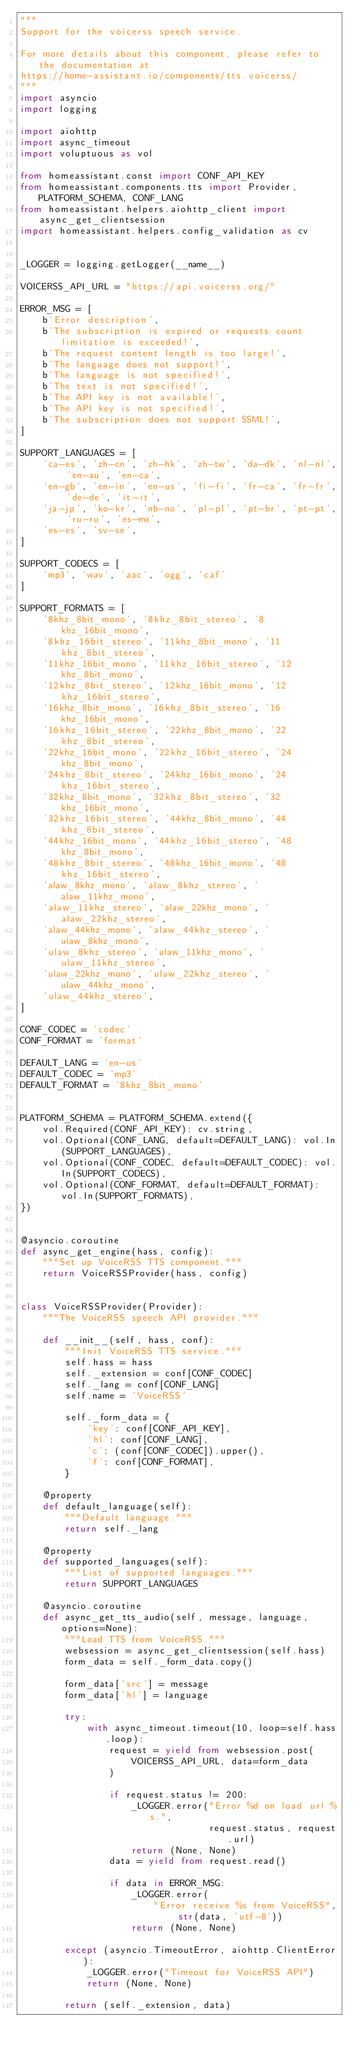<code> <loc_0><loc_0><loc_500><loc_500><_Python_>"""
Support for the voicerss speech service.

For more details about this component, please refer to the documentation at
https://home-assistant.io/components/tts.voicerss/
"""
import asyncio
import logging

import aiohttp
import async_timeout
import voluptuous as vol

from homeassistant.const import CONF_API_KEY
from homeassistant.components.tts import Provider, PLATFORM_SCHEMA, CONF_LANG
from homeassistant.helpers.aiohttp_client import async_get_clientsession
import homeassistant.helpers.config_validation as cv


_LOGGER = logging.getLogger(__name__)

VOICERSS_API_URL = "https://api.voicerss.org/"

ERROR_MSG = [
    b'Error description',
    b'The subscription is expired or requests count limitation is exceeded!',
    b'The request content length is too large!',
    b'The language does not support!',
    b'The language is not specified!',
    b'The text is not specified!',
    b'The API key is not available!',
    b'The API key is not specified!',
    b'The subscription does not support SSML!',
]

SUPPORT_LANGUAGES = [
    'ca-es', 'zh-cn', 'zh-hk', 'zh-tw', 'da-dk', 'nl-nl', 'en-au', 'en-ca',
    'en-gb', 'en-in', 'en-us', 'fi-fi', 'fr-ca', 'fr-fr', 'de-de', 'it-it',
    'ja-jp', 'ko-kr', 'nb-no', 'pl-pl', 'pt-br', 'pt-pt', 'ru-ru', 'es-mx',
    'es-es', 'sv-se',
]

SUPPORT_CODECS = [
    'mp3', 'wav', 'aac', 'ogg', 'caf'
]

SUPPORT_FORMATS = [
    '8khz_8bit_mono', '8khz_8bit_stereo', '8khz_16bit_mono',
    '8khz_16bit_stereo', '11khz_8bit_mono', '11khz_8bit_stereo',
    '11khz_16bit_mono', '11khz_16bit_stereo', '12khz_8bit_mono',
    '12khz_8bit_stereo', '12khz_16bit_mono', '12khz_16bit_stereo',
    '16khz_8bit_mono', '16khz_8bit_stereo', '16khz_16bit_mono',
    '16khz_16bit_stereo', '22khz_8bit_mono', '22khz_8bit_stereo',
    '22khz_16bit_mono', '22khz_16bit_stereo', '24khz_8bit_mono',
    '24khz_8bit_stereo', '24khz_16bit_mono', '24khz_16bit_stereo',
    '32khz_8bit_mono', '32khz_8bit_stereo', '32khz_16bit_mono',
    '32khz_16bit_stereo', '44khz_8bit_mono', '44khz_8bit_stereo',
    '44khz_16bit_mono', '44khz_16bit_stereo', '48khz_8bit_mono',
    '48khz_8bit_stereo', '48khz_16bit_mono', '48khz_16bit_stereo',
    'alaw_8khz_mono', 'alaw_8khz_stereo', 'alaw_11khz_mono',
    'alaw_11khz_stereo', 'alaw_22khz_mono', 'alaw_22khz_stereo',
    'alaw_44khz_mono', 'alaw_44khz_stereo', 'ulaw_8khz_mono',
    'ulaw_8khz_stereo', 'ulaw_11khz_mono', 'ulaw_11khz_stereo',
    'ulaw_22khz_mono', 'ulaw_22khz_stereo', 'ulaw_44khz_mono',
    'ulaw_44khz_stereo',
]

CONF_CODEC = 'codec'
CONF_FORMAT = 'format'

DEFAULT_LANG = 'en-us'
DEFAULT_CODEC = 'mp3'
DEFAULT_FORMAT = '8khz_8bit_mono'


PLATFORM_SCHEMA = PLATFORM_SCHEMA.extend({
    vol.Required(CONF_API_KEY): cv.string,
    vol.Optional(CONF_LANG, default=DEFAULT_LANG): vol.In(SUPPORT_LANGUAGES),
    vol.Optional(CONF_CODEC, default=DEFAULT_CODEC): vol.In(SUPPORT_CODECS),
    vol.Optional(CONF_FORMAT, default=DEFAULT_FORMAT): vol.In(SUPPORT_FORMATS),
})


@asyncio.coroutine
def async_get_engine(hass, config):
    """Set up VoiceRSS TTS component."""
    return VoiceRSSProvider(hass, config)


class VoiceRSSProvider(Provider):
    """The VoiceRSS speech API provider."""

    def __init__(self, hass, conf):
        """Init VoiceRSS TTS service."""
        self.hass = hass
        self._extension = conf[CONF_CODEC]
        self._lang = conf[CONF_LANG]
        self.name = 'VoiceRSS'

        self._form_data = {
            'key': conf[CONF_API_KEY],
            'hl': conf[CONF_LANG],
            'c': (conf[CONF_CODEC]).upper(),
            'f': conf[CONF_FORMAT],
        }

    @property
    def default_language(self):
        """Default language."""
        return self._lang

    @property
    def supported_languages(self):
        """List of supported languages."""
        return SUPPORT_LANGUAGES

    @asyncio.coroutine
    def async_get_tts_audio(self, message, language, options=None):
        """Load TTS from VoiceRSS."""
        websession = async_get_clientsession(self.hass)
        form_data = self._form_data.copy()

        form_data['src'] = message
        form_data['hl'] = language

        try:
            with async_timeout.timeout(10, loop=self.hass.loop):
                request = yield from websession.post(
                    VOICERSS_API_URL, data=form_data
                )

                if request.status != 200:
                    _LOGGER.error("Error %d on load url %s.",
                                  request.status, request.url)
                    return (None, None)
                data = yield from request.read()

                if data in ERROR_MSG:
                    _LOGGER.error(
                        "Error receive %s from VoiceRSS", str(data, 'utf-8'))
                    return (None, None)

        except (asyncio.TimeoutError, aiohttp.ClientError):
            _LOGGER.error("Timeout for VoiceRSS API")
            return (None, None)

        return (self._extension, data)
</code> 